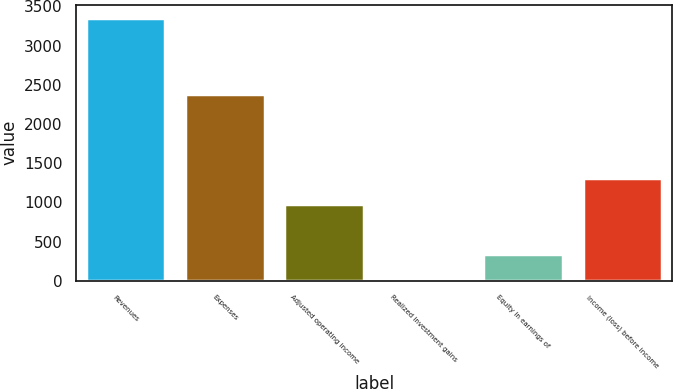Convert chart. <chart><loc_0><loc_0><loc_500><loc_500><bar_chart><fcel>Revenues<fcel>Expenses<fcel>Adjusted operating income<fcel>Realized investment gains<fcel>Equity in earnings of<fcel>Income (loss) before income<nl><fcel>3355<fcel>2376<fcel>979<fcel>4<fcel>339.1<fcel>1314.1<nl></chart> 